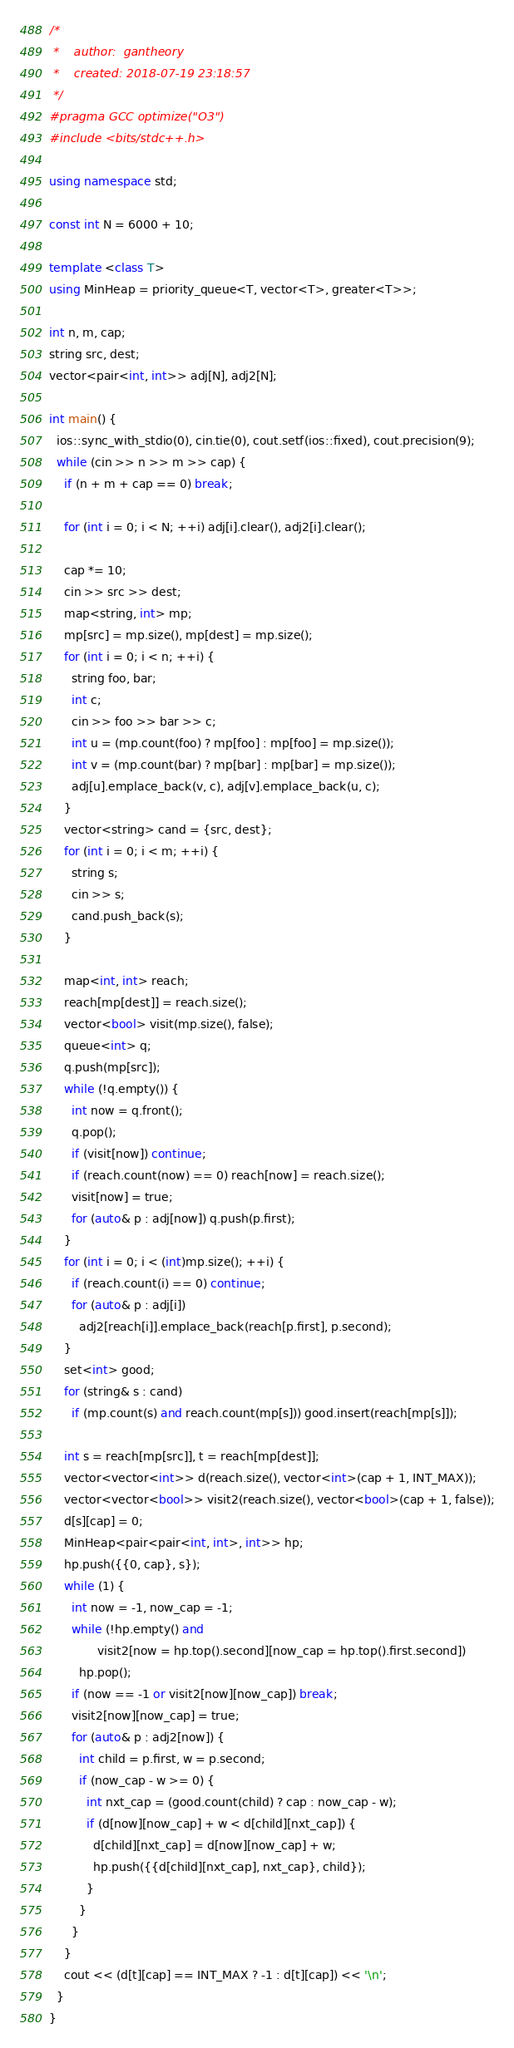<code> <loc_0><loc_0><loc_500><loc_500><_C++_>/*
 *    author:  gantheory
 *    created: 2018-07-19 23:18:57
 */
#pragma GCC optimize("O3")
#include <bits/stdc++.h>

using namespace std;

const int N = 6000 + 10;

template <class T>
using MinHeap = priority_queue<T, vector<T>, greater<T>>;

int n, m, cap;
string src, dest;
vector<pair<int, int>> adj[N], adj2[N];

int main() {
  ios::sync_with_stdio(0), cin.tie(0), cout.setf(ios::fixed), cout.precision(9);
  while (cin >> n >> m >> cap) {
    if (n + m + cap == 0) break;

    for (int i = 0; i < N; ++i) adj[i].clear(), adj2[i].clear();

    cap *= 10;
    cin >> src >> dest;
    map<string, int> mp;
    mp[src] = mp.size(), mp[dest] = mp.size();
    for (int i = 0; i < n; ++i) {
      string foo, bar;
      int c;
      cin >> foo >> bar >> c;
      int u = (mp.count(foo) ? mp[foo] : mp[foo] = mp.size());
      int v = (mp.count(bar) ? mp[bar] : mp[bar] = mp.size());
      adj[u].emplace_back(v, c), adj[v].emplace_back(u, c);
    }
    vector<string> cand = {src, dest};
    for (int i = 0; i < m; ++i) {
      string s;
      cin >> s;
      cand.push_back(s);
    }

    map<int, int> reach;
    reach[mp[dest]] = reach.size();
    vector<bool> visit(mp.size(), false);
    queue<int> q;
    q.push(mp[src]);
    while (!q.empty()) {
      int now = q.front();
      q.pop();
      if (visit[now]) continue;
      if (reach.count(now) == 0) reach[now] = reach.size();
      visit[now] = true;
      for (auto& p : adj[now]) q.push(p.first);
    }
    for (int i = 0; i < (int)mp.size(); ++i) {
      if (reach.count(i) == 0) continue;
      for (auto& p : adj[i])
        adj2[reach[i]].emplace_back(reach[p.first], p.second);
    }
    set<int> good;
    for (string& s : cand)
      if (mp.count(s) and reach.count(mp[s])) good.insert(reach[mp[s]]);

    int s = reach[mp[src]], t = reach[mp[dest]];
    vector<vector<int>> d(reach.size(), vector<int>(cap + 1, INT_MAX));
    vector<vector<bool>> visit2(reach.size(), vector<bool>(cap + 1, false));
    d[s][cap] = 0;
    MinHeap<pair<pair<int, int>, int>> hp;
    hp.push({{0, cap}, s});
    while (1) {
      int now = -1, now_cap = -1;
      while (!hp.empty() and
             visit2[now = hp.top().second][now_cap = hp.top().first.second])
        hp.pop();
      if (now == -1 or visit2[now][now_cap]) break;
      visit2[now][now_cap] = true;
      for (auto& p : adj2[now]) {
        int child = p.first, w = p.second;
        if (now_cap - w >= 0) {
          int nxt_cap = (good.count(child) ? cap : now_cap - w);
          if (d[now][now_cap] + w < d[child][nxt_cap]) {
            d[child][nxt_cap] = d[now][now_cap] + w;
            hp.push({{d[child][nxt_cap], nxt_cap}, child});
          }
        }
      }
    }
    cout << (d[t][cap] == INT_MAX ? -1 : d[t][cap]) << '\n';
  }
}

</code> 